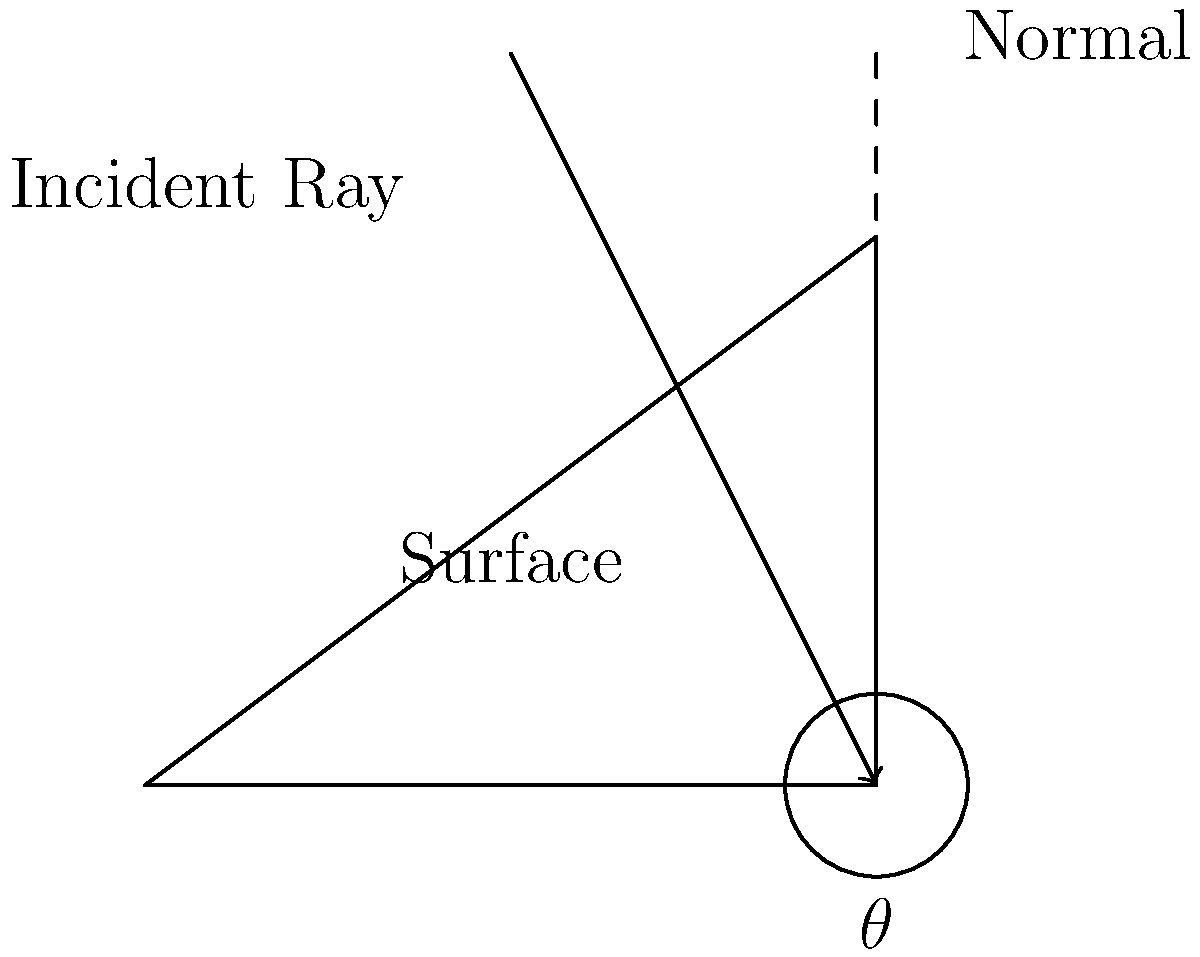In architectural video mapping, you're projecting onto an angled surface as shown in the diagram. If the angle between the surface and the horizontal is 36.87°, what is the angle of incidence ($\theta$) for the projection to be perpendicular to the surface? To find the angle of incidence ($\theta$) for the projection to be perpendicular to the surface, we can follow these steps:

1. Recall that for a projection to be perpendicular to a surface, the incident ray must align with the normal line to the surface.

2. The normal line is always perpendicular (90°) to the surface.

3. Given that the angle between the surface and the horizontal is 36.87°, we can determine that the angle between the normal line and the vertical is also 36.87°. This is because the normal line and the surface form complementary angles with the horizontal and vertical lines respectively.

4. The angle of incidence ($\theta$) is measured from the vertical line to the incident ray.

5. Since we want the incident ray to align with the normal line, the angle of incidence ($\theta$) must be equal to the angle between the normal line and the vertical.

6. Therefore, the angle of incidence ($\theta$) should be 36.87°.

This ensures that the projection is perpendicular to the angled surface, which is crucial for maintaining image quality and avoiding distortion in architectural video mapping.
Answer: 36.87° 